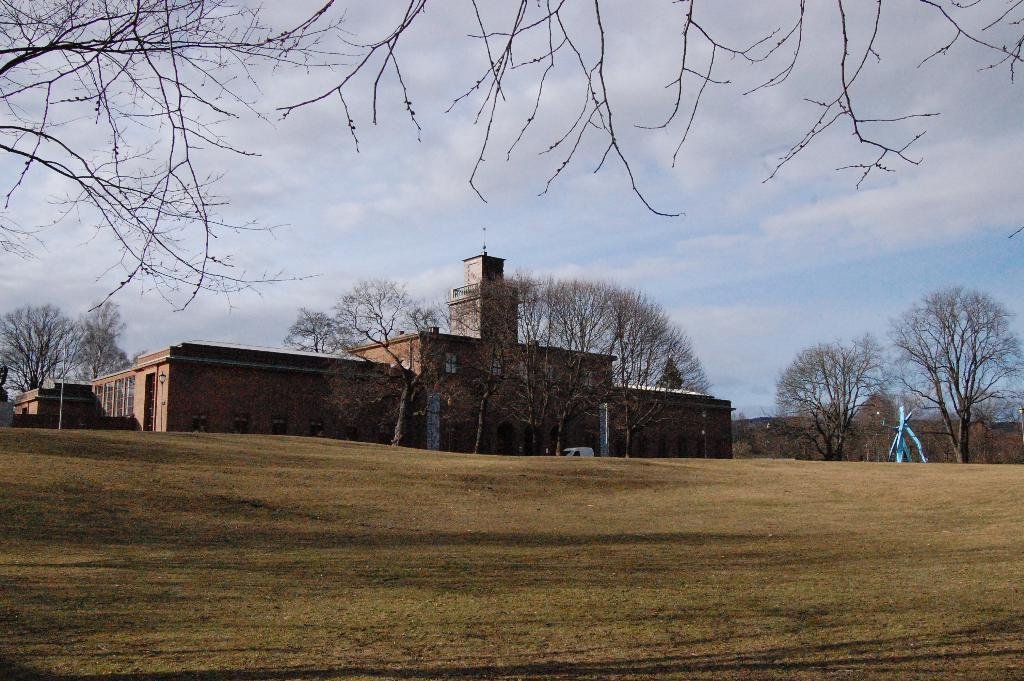What type of structures can be seen in the image? There are buildings in the image. What else is present in the image besides the buildings? There is a vehicle and trees visible in the image. What can be seen in the background of the image? The sky is visible in the background of the image. Where is the library located in the image? There is no library present in the image. What type of love can be seen between the buildings in the image? There is no love depicted between the buildings in the image; it is a photograph of structures and not an expression of emotion. 